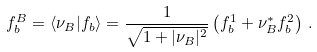<formula> <loc_0><loc_0><loc_500><loc_500>f _ { b } ^ { B } = \langle \nu _ { B } | f _ { b } \rangle = { \frac { 1 } { \sqrt { 1 + | \nu _ { B } | ^ { 2 } } } } \left ( f _ { b } ^ { 1 } + \nu _ { B } ^ { * } f _ { b } ^ { 2 } \right ) \, .</formula> 